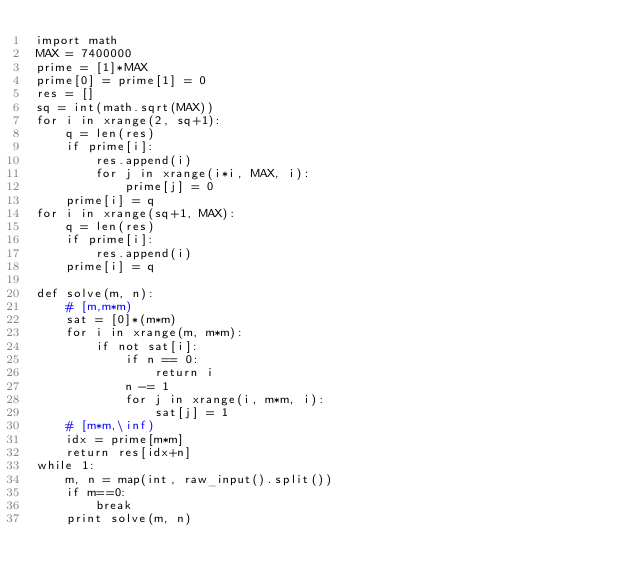<code> <loc_0><loc_0><loc_500><loc_500><_Python_>import math
MAX = 7400000
prime = [1]*MAX
prime[0] = prime[1] = 0
res = []
sq = int(math.sqrt(MAX))
for i in xrange(2, sq+1):
    q = len(res)
    if prime[i]:
        res.append(i)
        for j in xrange(i*i, MAX, i):
            prime[j] = 0
    prime[i] = q
for i in xrange(sq+1, MAX):
    q = len(res)
    if prime[i]:
        res.append(i)
    prime[i] = q

def solve(m, n):
    # [m,m*m)
    sat = [0]*(m*m)
    for i in xrange(m, m*m):
        if not sat[i]:
            if n == 0:
                return i
            n -= 1
            for j in xrange(i, m*m, i):
                sat[j] = 1
    # [m*m,\inf)
    idx = prime[m*m]
    return res[idx+n]
while 1:
    m, n = map(int, raw_input().split())
    if m==0:
        break
    print solve(m, n)</code> 